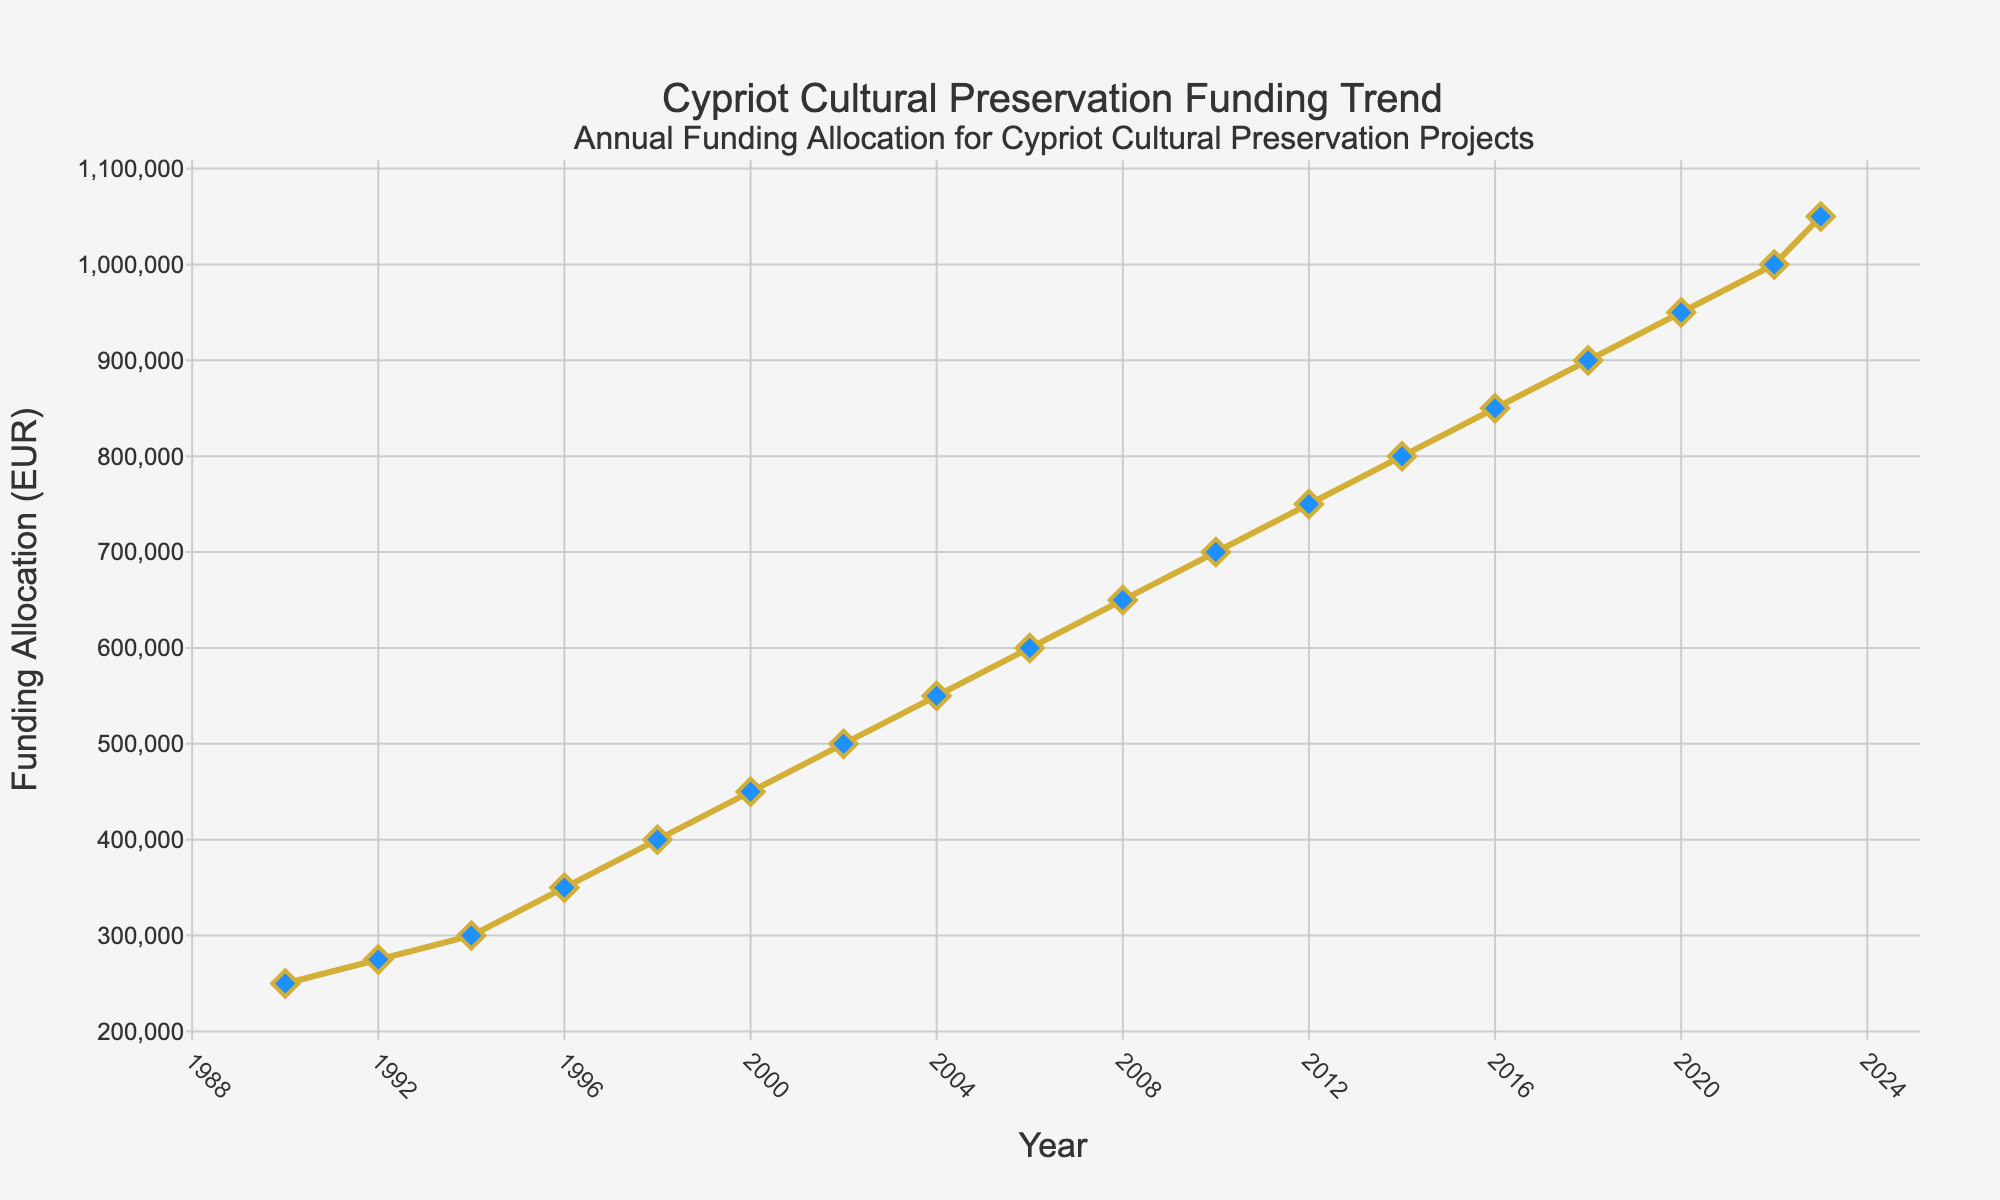What's the funding allocation in 2000? The figure has markers at each data point representing the funding allocation for each year. Locate the year 2000 on the x-axis and find the corresponding point on the y-axis. The funding allocation for 2000 is directly associated with this point.
Answer: 450,000 EUR How much did the funding allocation increase between 1990 and 2023? Find the funding allocation for 1990 and 2023 on the y-axis. Subtract the 1990 value from the 2023 value. The 2023 allocation is 1,050,000 EUR and the 1990 allocation is 250,000 EUR. Thus, the increase is 1,050,000 EUR - 250,000 EUR = 800,000 EUR
Answer: 800,000 EUR What is the average funding allocation from 1990 to 2023? Sum the funding allocations for all listed years, then divide by the number of years. The values are: 250,000, 275,000, 300,000, 350,000, 400,000, 450,000, 500,000, 550,000, 600,000, 650,000, 700,000, 750,000, 800,000, 850,000, 900,000, 950,000, 1,000,000, and 1,050,000 EUR. There are 18 data points, so the calculation is (250,000 + 275,000 + 300,000 + 350,000 + 400,000 + 450,000 + 500,000 + 550,000 + 600,000 + 650,000 + 700,000 + 750,000 + 800,000 + 850,000 + 900,000 + 950,000 + 1,000,000 + 1,050,000) / 18 = 625,000 EUR
Answer: 625,000 EUR Between which two consecutive years was the funding allocation increase the highest? Identify the differences in funding allocations between consecutive years by visually inspecting the steepness of the lines between markers. The largest visual vertical jump occurs between 2022 and 2023, where the funding increases from 1,000,000 to 1,050,000 EUR, a 50,000 EUR increase.
Answer: 2022 and 2023 How does the funding allocation in 2016 compare to that in 1992? Locate the funding allocations for both 2016 and 1992 on the y-axis. The value for 2016 is 850,000 EUR and for 1992 is 275,000 EUR. Compare these values directly.
Answer: 2016 funding is higher What is the overall trend of the funding allocation from 1990 to 2023? Examine the plotline over time from 1990 to 2023. Notice the general direction and shape of the graph. The markers and lines mostly move upwards, indicating an increasing trend over time.
Answer: Increasing trend What is the percentage increase in funding from 1998 to 2022? First, find the funding allocations for 1998 and 2022. The values are 400,000 EUR in 1998 and 1,000,000 EUR in 2022. Use the formula for percentage increase: ((New Value - Old Value) / Old Value) * 100. Substituting the values: ((1,000,000 - 400,000) / 400,000) * 100 = 150%
Answer: 150% Which year had the smallest funding allocation increase compared to its previous year? Calculate the difference between funding allocations for consecutive years. The smallest difference visually can be found between years: comparing incremental increases, the smallest difference is 1990 to 1992 with a 25,000 EUR increase (from 250,000 to 275,000 EUR).
Answer: Between 1990 and 1992 What was the funding allocation amount in 2010 and how much did it grow by 2014? Refer to the plot to find the funding allocations for 2010 and 2014. For 2010, the allocation is 700,000 EUR, and for 2014, it is 800,000 EUR. The growth is calculated as 800,000 - 700,000 = 100,000 EUR.
Answer: 100,000 EUR Is there any year where the funding allocation stayed the same as the previous year? Check the plot for consecutive years where the markers lie at the same y-axis value. After inspection, there is no year where the funding allocation remains constant compared to the previous year.
Answer: No 